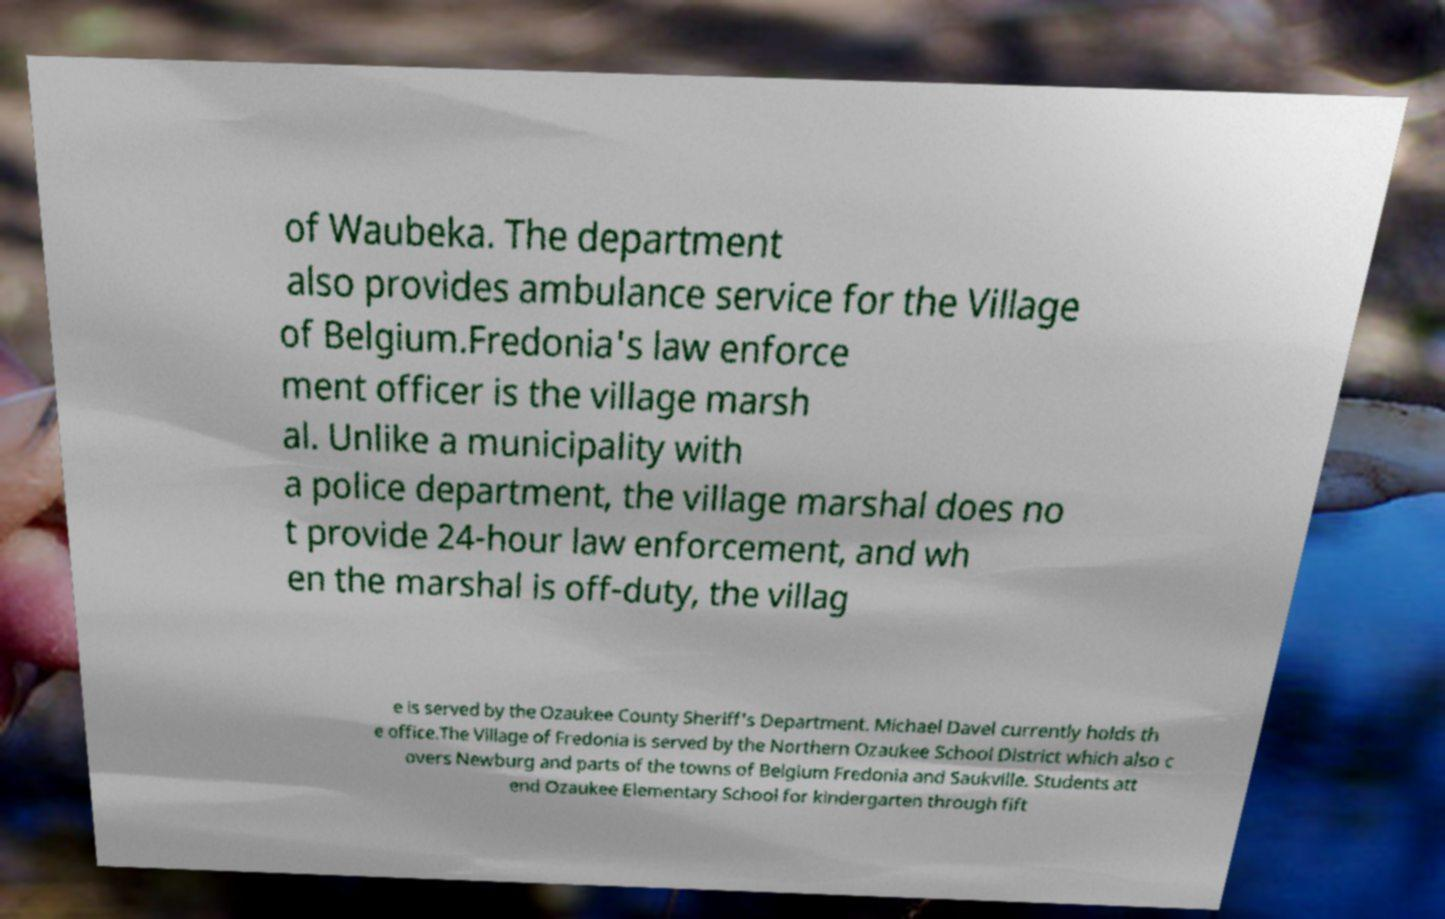There's text embedded in this image that I need extracted. Can you transcribe it verbatim? of Waubeka. The department also provides ambulance service for the Village of Belgium.Fredonia's law enforce ment officer is the village marsh al. Unlike a municipality with a police department, the village marshal does no t provide 24-hour law enforcement, and wh en the marshal is off-duty, the villag e is served by the Ozaukee County Sheriff's Department. Michael Davel currently holds th e office.The Village of Fredonia is served by the Northern Ozaukee School District which also c overs Newburg and parts of the towns of Belgium Fredonia and Saukville. Students att end Ozaukee Elementary School for kindergarten through fift 